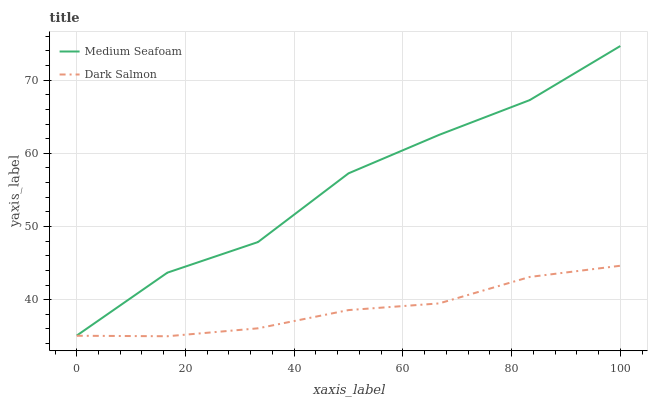Does Dark Salmon have the minimum area under the curve?
Answer yes or no. Yes. Does Medium Seafoam have the maximum area under the curve?
Answer yes or no. Yes. Does Dark Salmon have the maximum area under the curve?
Answer yes or no. No. Is Dark Salmon the smoothest?
Answer yes or no. Yes. Is Medium Seafoam the roughest?
Answer yes or no. Yes. Is Dark Salmon the roughest?
Answer yes or no. No. Does Dark Salmon have the lowest value?
Answer yes or no. Yes. Does Medium Seafoam have the highest value?
Answer yes or no. Yes. Does Dark Salmon have the highest value?
Answer yes or no. No. Is Dark Salmon less than Medium Seafoam?
Answer yes or no. Yes. Is Medium Seafoam greater than Dark Salmon?
Answer yes or no. Yes. Does Dark Salmon intersect Medium Seafoam?
Answer yes or no. No. 